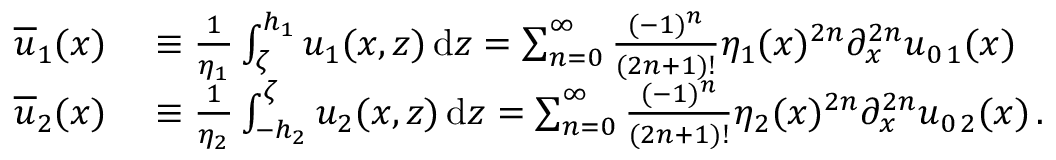Convert formula to latex. <formula><loc_0><loc_0><loc_500><loc_500>\begin{array} { r l } { { \overline { u } } _ { 1 } ( x ) } & \equiv \frac { 1 } { \eta _ { 1 } } \int _ { \zeta } ^ { h _ { 1 } } u _ { 1 } ( x , z ) \, d z = \sum _ { n = 0 } ^ { \infty } \frac { ( - 1 ) ^ { n } } { ( 2 n + 1 ) ! } \eta _ { 1 } ( x ) ^ { 2 n } \partial _ { x } ^ { 2 n } u _ { 0 \, 1 } ( x ) \, } \\ { { \overline { u } } _ { 2 } ( x ) } & \equiv \frac { 1 } { \eta _ { 2 } } \int _ { - h _ { 2 } } ^ { \zeta } u _ { 2 } ( x , z ) \, d z = \sum _ { n = 0 } ^ { \infty } \frac { ( - 1 ) ^ { n } } { ( 2 n + 1 ) ! } \eta _ { 2 } ( x ) ^ { 2 n } \partial _ { x } ^ { 2 n } u _ { 0 \, 2 } ( x ) \, . } \end{array}</formula> 